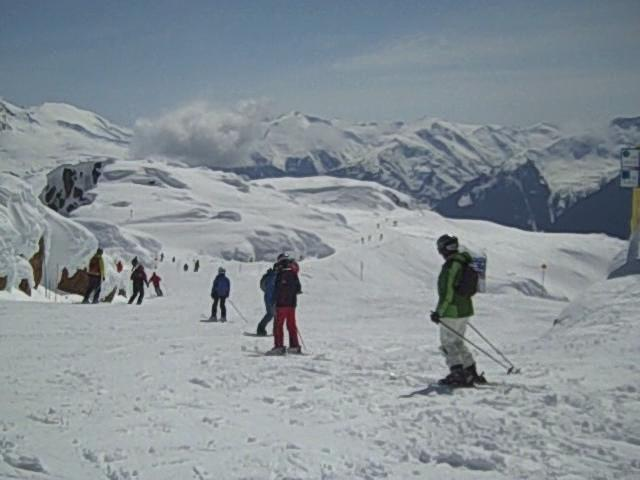What season brings this weather?

Choices:
A) winter
B) summer
C) fall
D) spring winter 